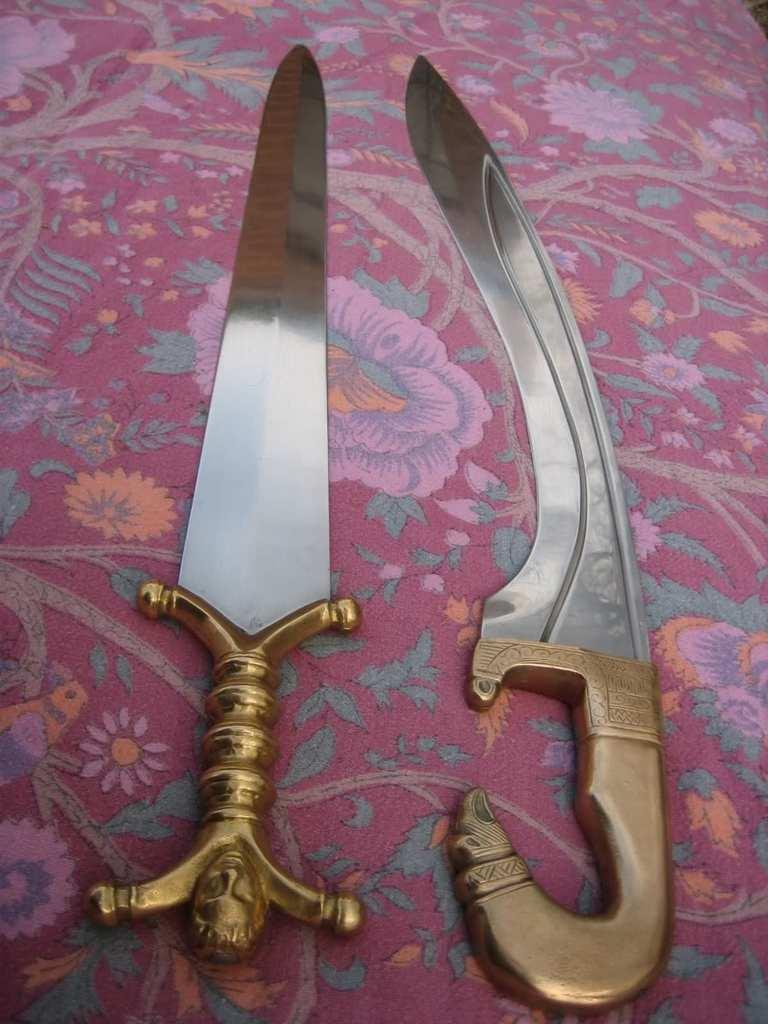What weapons are present in the image? There are two swords in the image. What is the swords resting on? The swords are on a cloth. What is the connection between the swords and the wave in the image? There is no wave present in the image, so there is no connection between the swords and a wave. 